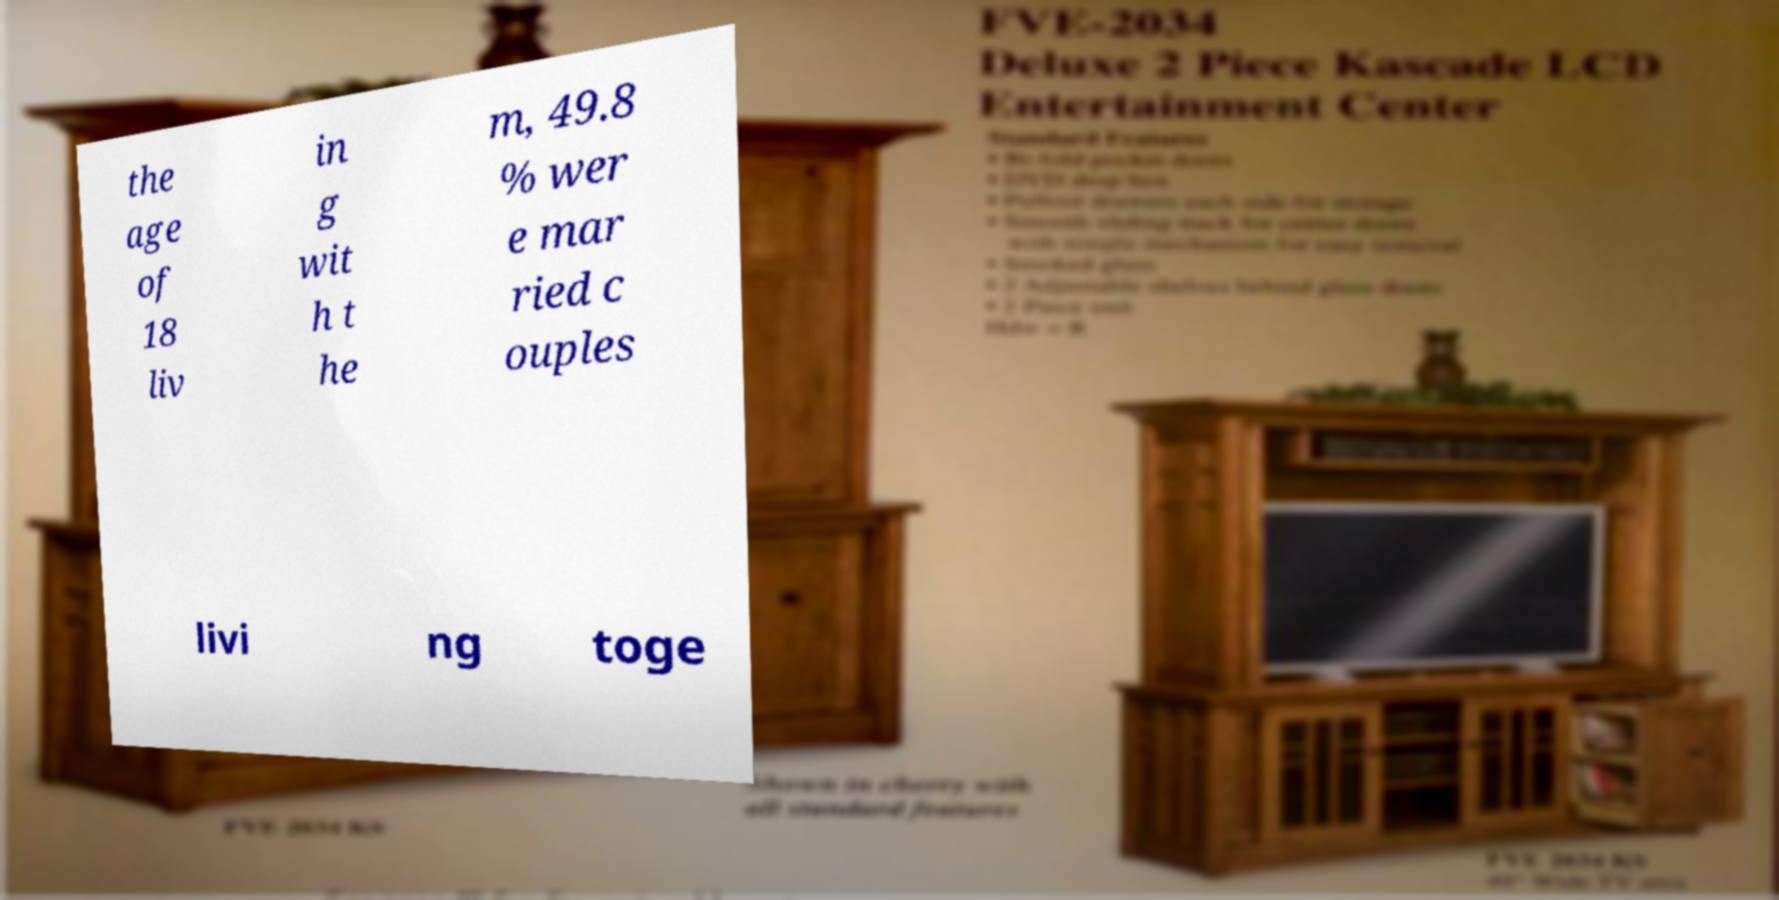Could you assist in decoding the text presented in this image and type it out clearly? the age of 18 liv in g wit h t he m, 49.8 % wer e mar ried c ouples livi ng toge 